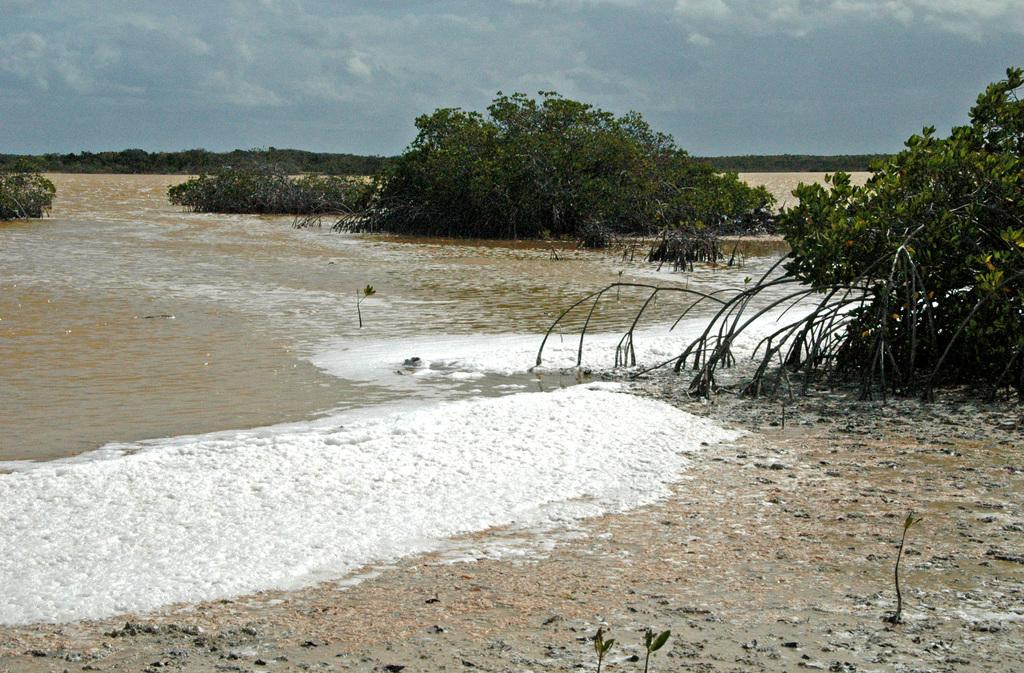What can be seen in the sky in the image? The sky with clouds is visible in the image. What type of vegetation is present in the image? There are trees in the image. What natural element is visible in the image besides the sky and trees? There is water visible in the image. What type of fruit is hanging from the trees in the image? There is no fruit visible in the image; only clouds, sky, trees, and water are present. Can you see a glove being used to collect stamps in the image? There is no glove or stamp-collecting activity present in the image. 